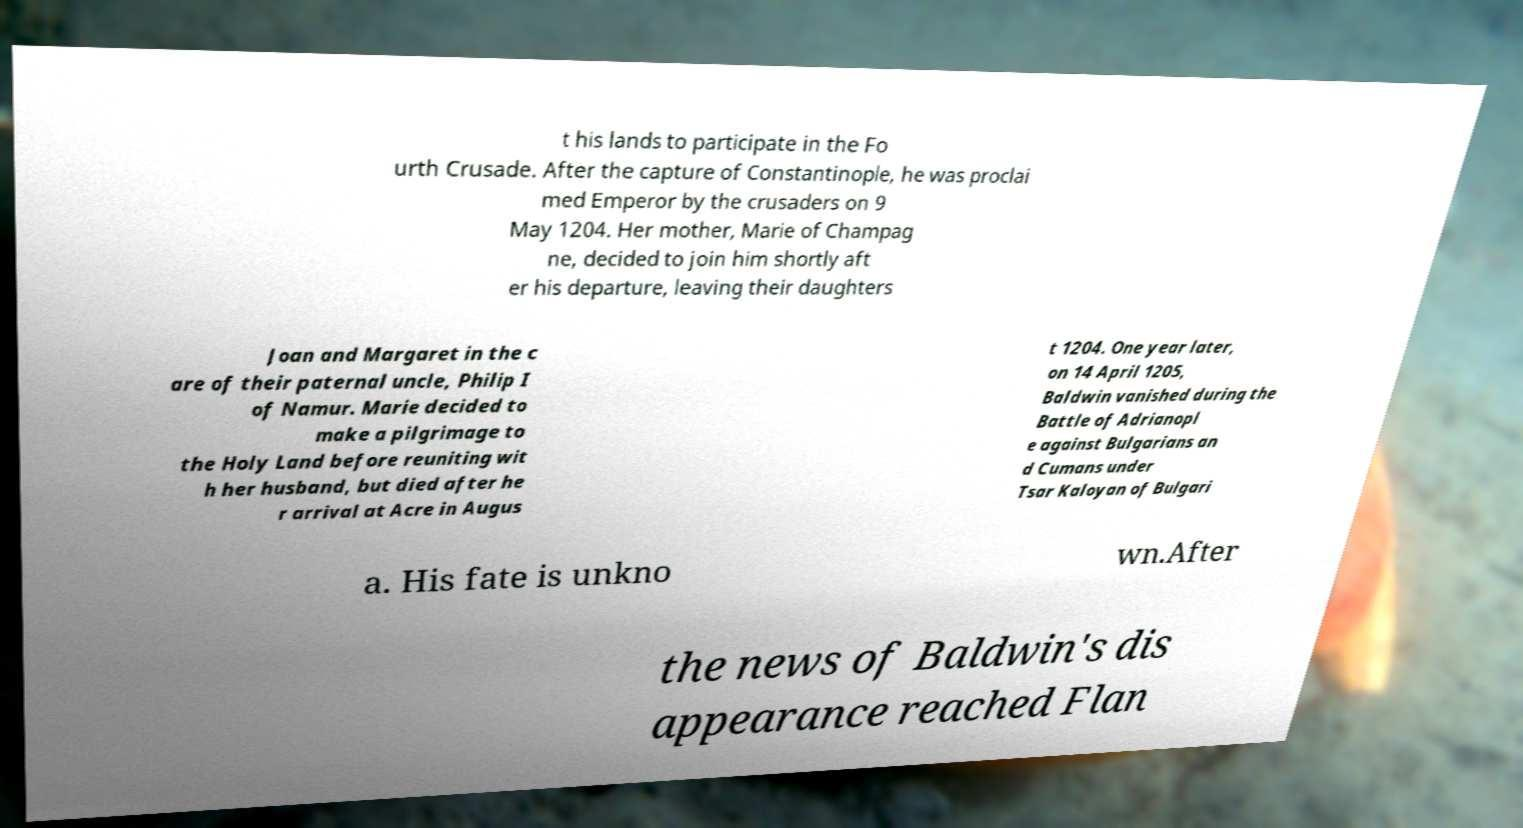Please identify and transcribe the text found in this image. t his lands to participate in the Fo urth Crusade. After the capture of Constantinople, he was proclai med Emperor by the crusaders on 9 May 1204. Her mother, Marie of Champag ne, decided to join him shortly aft er his departure, leaving their daughters Joan and Margaret in the c are of their paternal uncle, Philip I of Namur. Marie decided to make a pilgrimage to the Holy Land before reuniting wit h her husband, but died after he r arrival at Acre in Augus t 1204. One year later, on 14 April 1205, Baldwin vanished during the Battle of Adrianopl e against Bulgarians an d Cumans under Tsar Kaloyan of Bulgari a. His fate is unkno wn.After the news of Baldwin's dis appearance reached Flan 